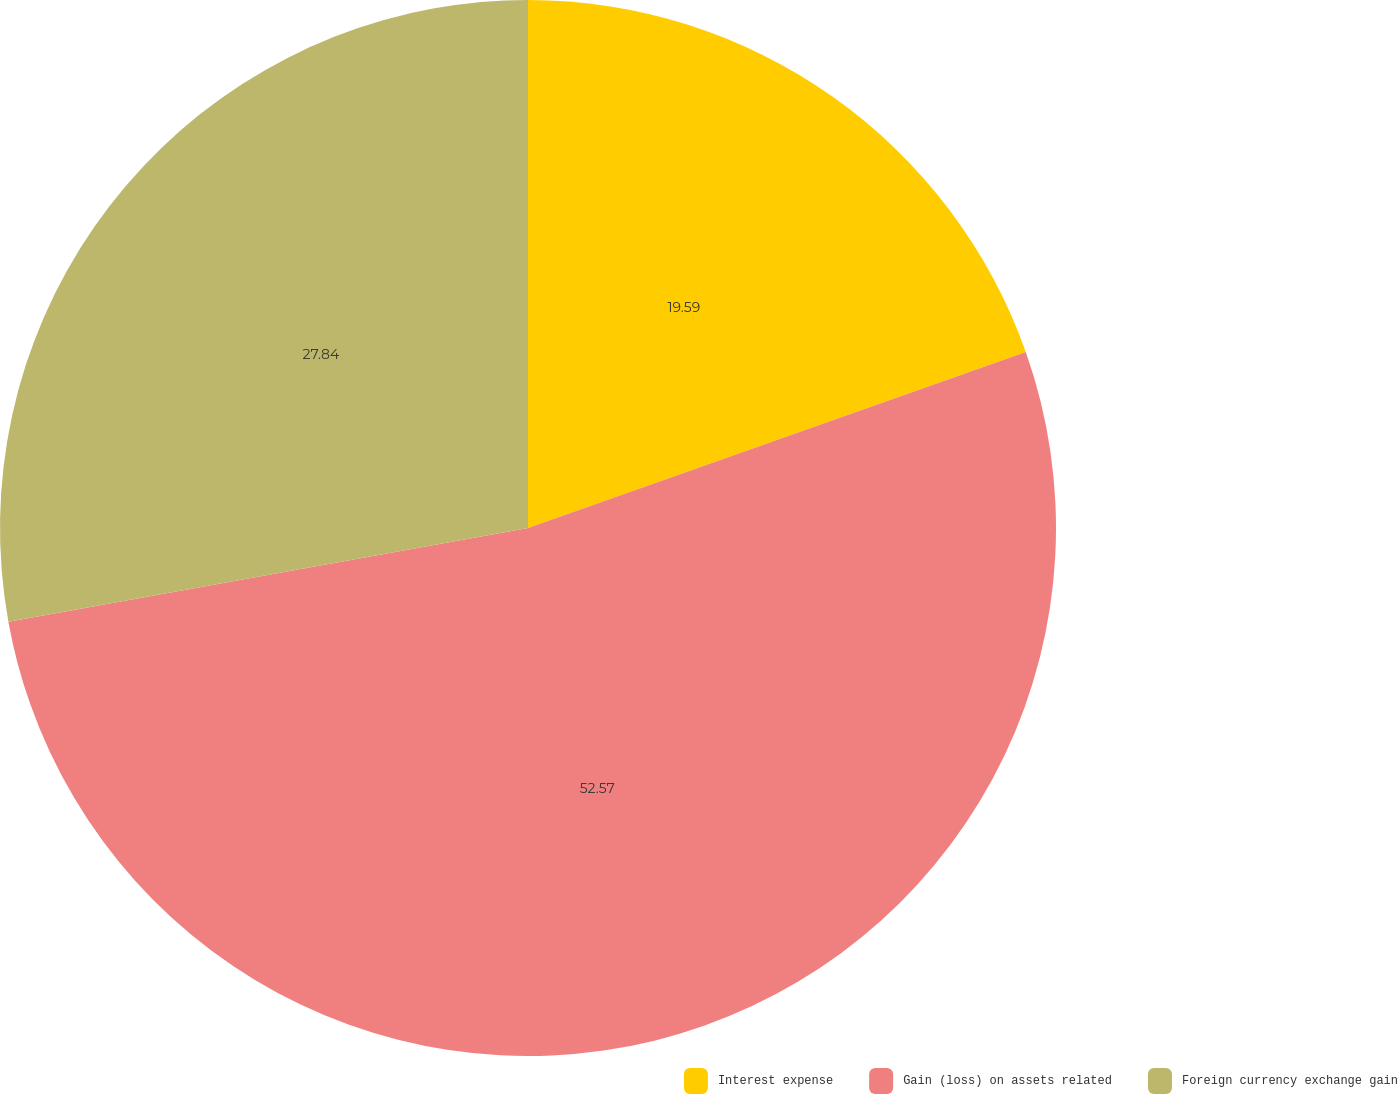Convert chart to OTSL. <chart><loc_0><loc_0><loc_500><loc_500><pie_chart><fcel>Interest expense<fcel>Gain (loss) on assets related<fcel>Foreign currency exchange gain<nl><fcel>19.59%<fcel>52.58%<fcel>27.84%<nl></chart> 